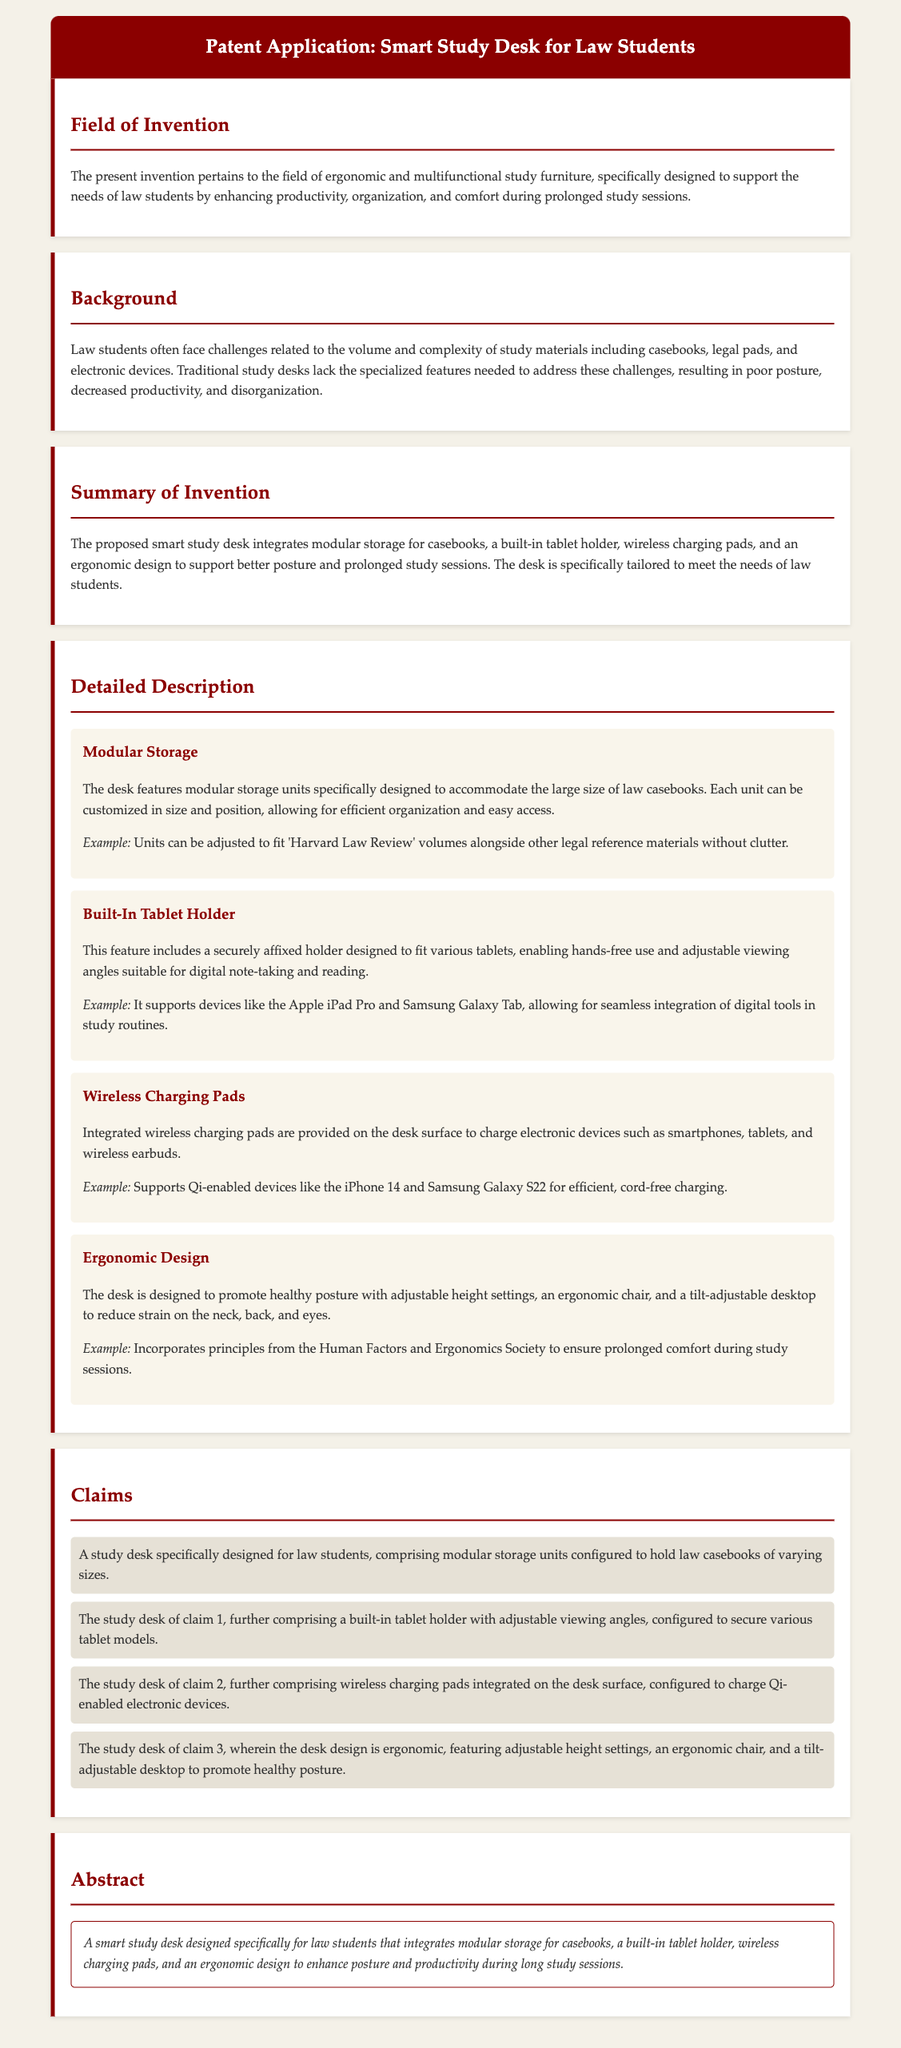What is the field of invention? The field of invention pertains to ergonomic and multifunctional study furniture, specifically designed for law students.
Answer: ergonomic and multifunctional study furniture What feature supports hands-free use? The feature that supports hands-free use is the built-in tablet holder.
Answer: built-in tablet holder What type of storage does the desk provide? The desk provides modular storage for law casebooks.
Answer: modular storage How many claims are made in the patent application? There are four claims made in the patent application.
Answer: four What is the purpose of the wireless charging pads? The purpose of the wireless charging pads is to charge Qi-enabled electronic devices.
Answer: charge Qi-enabled electronic devices What design principles are incorporated in the ergonomic design? The ergonomic design incorporates principles from the Human Factors and Ergonomics Society.
Answer: Human Factors and Ergonomics Society What does the abstract summarize? The abstract summarizes a smart study desk designed specifically for law students.
Answer: a smart study desk designed specifically for law students Which example is given for modular storage? The example given is to fit 'Harvard Law Review' volumes alongside other legal reference materials.
Answer: 'Harvard Law Review' volumes What does the desk's design aim to enhance? The desk's design aims to enhance posture during long study sessions.
Answer: enhance posture 